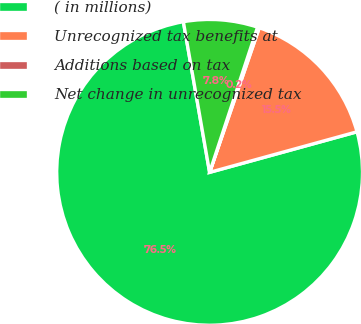<chart> <loc_0><loc_0><loc_500><loc_500><pie_chart><fcel>( in millions)<fcel>Unrecognized tax benefits at<fcel>Additions based on tax<fcel>Net change in unrecognized tax<nl><fcel>76.53%<fcel>15.46%<fcel>0.19%<fcel>7.82%<nl></chart> 